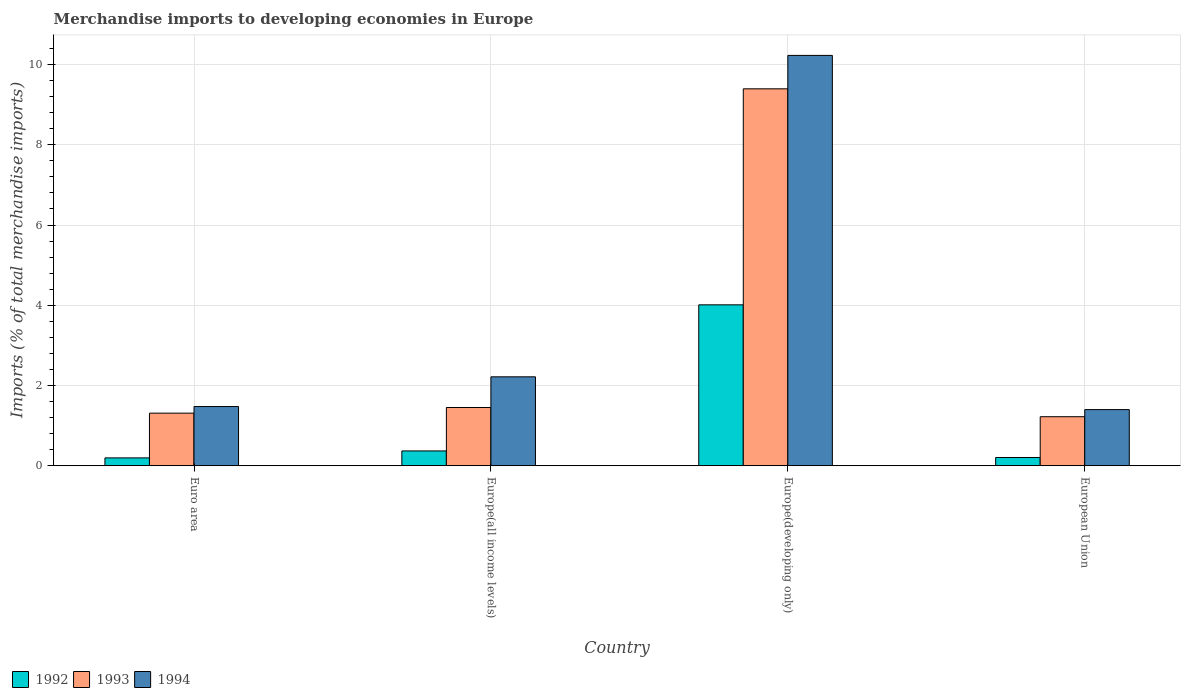How many different coloured bars are there?
Offer a very short reply. 3. Are the number of bars per tick equal to the number of legend labels?
Give a very brief answer. Yes. Are the number of bars on each tick of the X-axis equal?
Provide a short and direct response. Yes. How many bars are there on the 1st tick from the right?
Provide a short and direct response. 3. What is the label of the 2nd group of bars from the left?
Provide a succinct answer. Europe(all income levels). In how many cases, is the number of bars for a given country not equal to the number of legend labels?
Make the answer very short. 0. What is the percentage total merchandise imports in 1992 in Europe(developing only)?
Give a very brief answer. 4.01. Across all countries, what is the maximum percentage total merchandise imports in 1992?
Your answer should be compact. 4.01. Across all countries, what is the minimum percentage total merchandise imports in 1994?
Ensure brevity in your answer.  1.4. In which country was the percentage total merchandise imports in 1994 maximum?
Your answer should be compact. Europe(developing only). In which country was the percentage total merchandise imports in 1992 minimum?
Ensure brevity in your answer.  Euro area. What is the total percentage total merchandise imports in 1993 in the graph?
Make the answer very short. 13.38. What is the difference between the percentage total merchandise imports in 1992 in Euro area and that in Europe(developing only)?
Give a very brief answer. -3.82. What is the difference between the percentage total merchandise imports in 1993 in Europe(developing only) and the percentage total merchandise imports in 1994 in Europe(all income levels)?
Your answer should be very brief. 7.18. What is the average percentage total merchandise imports in 1993 per country?
Your answer should be very brief. 3.34. What is the difference between the percentage total merchandise imports of/in 1994 and percentage total merchandise imports of/in 1992 in Europe(all income levels)?
Offer a very short reply. 1.85. In how many countries, is the percentage total merchandise imports in 1993 greater than 0.8 %?
Your answer should be very brief. 4. What is the ratio of the percentage total merchandise imports in 1992 in Euro area to that in Europe(all income levels)?
Provide a short and direct response. 0.53. Is the difference between the percentage total merchandise imports in 1994 in Europe(all income levels) and European Union greater than the difference between the percentage total merchandise imports in 1992 in Europe(all income levels) and European Union?
Keep it short and to the point. Yes. What is the difference between the highest and the second highest percentage total merchandise imports in 1993?
Make the answer very short. 8.08. What is the difference between the highest and the lowest percentage total merchandise imports in 1993?
Your answer should be compact. 8.17. In how many countries, is the percentage total merchandise imports in 1994 greater than the average percentage total merchandise imports in 1994 taken over all countries?
Provide a short and direct response. 1. Is the sum of the percentage total merchandise imports in 1993 in Europe(all income levels) and European Union greater than the maximum percentage total merchandise imports in 1994 across all countries?
Your response must be concise. No. What does the 1st bar from the right in Europe(developing only) represents?
Make the answer very short. 1994. How many bars are there?
Your answer should be very brief. 12. Are all the bars in the graph horizontal?
Offer a very short reply. No. How many countries are there in the graph?
Provide a short and direct response. 4. What is the difference between two consecutive major ticks on the Y-axis?
Your answer should be very brief. 2. Are the values on the major ticks of Y-axis written in scientific E-notation?
Keep it short and to the point. No. Does the graph contain any zero values?
Give a very brief answer. No. Where does the legend appear in the graph?
Your response must be concise. Bottom left. What is the title of the graph?
Ensure brevity in your answer.  Merchandise imports to developing economies in Europe. Does "2009" appear as one of the legend labels in the graph?
Provide a succinct answer. No. What is the label or title of the Y-axis?
Offer a terse response. Imports (% of total merchandise imports). What is the Imports (% of total merchandise imports) of 1992 in Euro area?
Your answer should be very brief. 0.2. What is the Imports (% of total merchandise imports) of 1993 in Euro area?
Keep it short and to the point. 1.31. What is the Imports (% of total merchandise imports) in 1994 in Euro area?
Offer a terse response. 1.48. What is the Imports (% of total merchandise imports) in 1992 in Europe(all income levels)?
Your answer should be very brief. 0.37. What is the Imports (% of total merchandise imports) in 1993 in Europe(all income levels)?
Provide a short and direct response. 1.45. What is the Imports (% of total merchandise imports) of 1994 in Europe(all income levels)?
Give a very brief answer. 2.22. What is the Imports (% of total merchandise imports) in 1992 in Europe(developing only)?
Make the answer very short. 4.01. What is the Imports (% of total merchandise imports) in 1993 in Europe(developing only)?
Ensure brevity in your answer.  9.39. What is the Imports (% of total merchandise imports) of 1994 in Europe(developing only)?
Keep it short and to the point. 10.23. What is the Imports (% of total merchandise imports) of 1992 in European Union?
Your answer should be very brief. 0.21. What is the Imports (% of total merchandise imports) of 1993 in European Union?
Make the answer very short. 1.22. What is the Imports (% of total merchandise imports) of 1994 in European Union?
Ensure brevity in your answer.  1.4. Across all countries, what is the maximum Imports (% of total merchandise imports) in 1992?
Your response must be concise. 4.01. Across all countries, what is the maximum Imports (% of total merchandise imports) in 1993?
Provide a short and direct response. 9.39. Across all countries, what is the maximum Imports (% of total merchandise imports) in 1994?
Offer a terse response. 10.23. Across all countries, what is the minimum Imports (% of total merchandise imports) in 1992?
Offer a very short reply. 0.2. Across all countries, what is the minimum Imports (% of total merchandise imports) of 1993?
Provide a short and direct response. 1.22. Across all countries, what is the minimum Imports (% of total merchandise imports) of 1994?
Your answer should be compact. 1.4. What is the total Imports (% of total merchandise imports) in 1992 in the graph?
Your response must be concise. 4.78. What is the total Imports (% of total merchandise imports) of 1993 in the graph?
Your answer should be compact. 13.38. What is the total Imports (% of total merchandise imports) of 1994 in the graph?
Your response must be concise. 15.32. What is the difference between the Imports (% of total merchandise imports) in 1992 in Euro area and that in Europe(all income levels)?
Give a very brief answer. -0.17. What is the difference between the Imports (% of total merchandise imports) in 1993 in Euro area and that in Europe(all income levels)?
Offer a terse response. -0.14. What is the difference between the Imports (% of total merchandise imports) in 1994 in Euro area and that in Europe(all income levels)?
Your answer should be compact. -0.74. What is the difference between the Imports (% of total merchandise imports) of 1992 in Euro area and that in Europe(developing only)?
Ensure brevity in your answer.  -3.82. What is the difference between the Imports (% of total merchandise imports) in 1993 in Euro area and that in Europe(developing only)?
Keep it short and to the point. -8.08. What is the difference between the Imports (% of total merchandise imports) in 1994 in Euro area and that in Europe(developing only)?
Ensure brevity in your answer.  -8.75. What is the difference between the Imports (% of total merchandise imports) in 1992 in Euro area and that in European Union?
Provide a short and direct response. -0.01. What is the difference between the Imports (% of total merchandise imports) in 1993 in Euro area and that in European Union?
Ensure brevity in your answer.  0.09. What is the difference between the Imports (% of total merchandise imports) in 1994 in Euro area and that in European Union?
Provide a short and direct response. 0.08. What is the difference between the Imports (% of total merchandise imports) in 1992 in Europe(all income levels) and that in Europe(developing only)?
Your answer should be very brief. -3.64. What is the difference between the Imports (% of total merchandise imports) of 1993 in Europe(all income levels) and that in Europe(developing only)?
Give a very brief answer. -7.94. What is the difference between the Imports (% of total merchandise imports) in 1994 in Europe(all income levels) and that in Europe(developing only)?
Offer a terse response. -8.01. What is the difference between the Imports (% of total merchandise imports) of 1992 in Europe(all income levels) and that in European Union?
Offer a very short reply. 0.16. What is the difference between the Imports (% of total merchandise imports) in 1993 in Europe(all income levels) and that in European Union?
Provide a short and direct response. 0.23. What is the difference between the Imports (% of total merchandise imports) of 1994 in Europe(all income levels) and that in European Union?
Offer a terse response. 0.82. What is the difference between the Imports (% of total merchandise imports) of 1992 in Europe(developing only) and that in European Union?
Keep it short and to the point. 3.8. What is the difference between the Imports (% of total merchandise imports) in 1993 in Europe(developing only) and that in European Union?
Ensure brevity in your answer.  8.17. What is the difference between the Imports (% of total merchandise imports) of 1994 in Europe(developing only) and that in European Union?
Your answer should be compact. 8.83. What is the difference between the Imports (% of total merchandise imports) in 1992 in Euro area and the Imports (% of total merchandise imports) in 1993 in Europe(all income levels)?
Ensure brevity in your answer.  -1.26. What is the difference between the Imports (% of total merchandise imports) of 1992 in Euro area and the Imports (% of total merchandise imports) of 1994 in Europe(all income levels)?
Give a very brief answer. -2.02. What is the difference between the Imports (% of total merchandise imports) in 1993 in Euro area and the Imports (% of total merchandise imports) in 1994 in Europe(all income levels)?
Give a very brief answer. -0.91. What is the difference between the Imports (% of total merchandise imports) in 1992 in Euro area and the Imports (% of total merchandise imports) in 1993 in Europe(developing only)?
Provide a short and direct response. -9.2. What is the difference between the Imports (% of total merchandise imports) of 1992 in Euro area and the Imports (% of total merchandise imports) of 1994 in Europe(developing only)?
Provide a short and direct response. -10.03. What is the difference between the Imports (% of total merchandise imports) of 1993 in Euro area and the Imports (% of total merchandise imports) of 1994 in Europe(developing only)?
Keep it short and to the point. -8.92. What is the difference between the Imports (% of total merchandise imports) of 1992 in Euro area and the Imports (% of total merchandise imports) of 1993 in European Union?
Your answer should be very brief. -1.03. What is the difference between the Imports (% of total merchandise imports) of 1992 in Euro area and the Imports (% of total merchandise imports) of 1994 in European Union?
Give a very brief answer. -1.2. What is the difference between the Imports (% of total merchandise imports) of 1993 in Euro area and the Imports (% of total merchandise imports) of 1994 in European Union?
Your response must be concise. -0.09. What is the difference between the Imports (% of total merchandise imports) of 1992 in Europe(all income levels) and the Imports (% of total merchandise imports) of 1993 in Europe(developing only)?
Offer a very short reply. -9.03. What is the difference between the Imports (% of total merchandise imports) of 1992 in Europe(all income levels) and the Imports (% of total merchandise imports) of 1994 in Europe(developing only)?
Provide a succinct answer. -9.86. What is the difference between the Imports (% of total merchandise imports) in 1993 in Europe(all income levels) and the Imports (% of total merchandise imports) in 1994 in Europe(developing only)?
Provide a short and direct response. -8.78. What is the difference between the Imports (% of total merchandise imports) in 1992 in Europe(all income levels) and the Imports (% of total merchandise imports) in 1993 in European Union?
Offer a very short reply. -0.85. What is the difference between the Imports (% of total merchandise imports) of 1992 in Europe(all income levels) and the Imports (% of total merchandise imports) of 1994 in European Union?
Offer a terse response. -1.03. What is the difference between the Imports (% of total merchandise imports) in 1993 in Europe(all income levels) and the Imports (% of total merchandise imports) in 1994 in European Union?
Provide a succinct answer. 0.05. What is the difference between the Imports (% of total merchandise imports) in 1992 in Europe(developing only) and the Imports (% of total merchandise imports) in 1993 in European Union?
Your answer should be compact. 2.79. What is the difference between the Imports (% of total merchandise imports) of 1992 in Europe(developing only) and the Imports (% of total merchandise imports) of 1994 in European Union?
Give a very brief answer. 2.61. What is the difference between the Imports (% of total merchandise imports) in 1993 in Europe(developing only) and the Imports (% of total merchandise imports) in 1994 in European Union?
Keep it short and to the point. 8. What is the average Imports (% of total merchandise imports) in 1992 per country?
Provide a short and direct response. 1.2. What is the average Imports (% of total merchandise imports) in 1993 per country?
Give a very brief answer. 3.34. What is the average Imports (% of total merchandise imports) of 1994 per country?
Offer a very short reply. 3.83. What is the difference between the Imports (% of total merchandise imports) in 1992 and Imports (% of total merchandise imports) in 1993 in Euro area?
Ensure brevity in your answer.  -1.12. What is the difference between the Imports (% of total merchandise imports) in 1992 and Imports (% of total merchandise imports) in 1994 in Euro area?
Your answer should be very brief. -1.28. What is the difference between the Imports (% of total merchandise imports) of 1993 and Imports (% of total merchandise imports) of 1994 in Euro area?
Your answer should be very brief. -0.16. What is the difference between the Imports (% of total merchandise imports) of 1992 and Imports (% of total merchandise imports) of 1993 in Europe(all income levels)?
Give a very brief answer. -1.08. What is the difference between the Imports (% of total merchandise imports) of 1992 and Imports (% of total merchandise imports) of 1994 in Europe(all income levels)?
Give a very brief answer. -1.85. What is the difference between the Imports (% of total merchandise imports) of 1993 and Imports (% of total merchandise imports) of 1994 in Europe(all income levels)?
Give a very brief answer. -0.76. What is the difference between the Imports (% of total merchandise imports) of 1992 and Imports (% of total merchandise imports) of 1993 in Europe(developing only)?
Offer a very short reply. -5.38. What is the difference between the Imports (% of total merchandise imports) in 1992 and Imports (% of total merchandise imports) in 1994 in Europe(developing only)?
Offer a very short reply. -6.22. What is the difference between the Imports (% of total merchandise imports) in 1993 and Imports (% of total merchandise imports) in 1994 in Europe(developing only)?
Your answer should be very brief. -0.83. What is the difference between the Imports (% of total merchandise imports) in 1992 and Imports (% of total merchandise imports) in 1993 in European Union?
Provide a succinct answer. -1.02. What is the difference between the Imports (% of total merchandise imports) in 1992 and Imports (% of total merchandise imports) in 1994 in European Union?
Give a very brief answer. -1.19. What is the difference between the Imports (% of total merchandise imports) in 1993 and Imports (% of total merchandise imports) in 1994 in European Union?
Keep it short and to the point. -0.18. What is the ratio of the Imports (% of total merchandise imports) of 1992 in Euro area to that in Europe(all income levels)?
Ensure brevity in your answer.  0.53. What is the ratio of the Imports (% of total merchandise imports) in 1993 in Euro area to that in Europe(all income levels)?
Make the answer very short. 0.9. What is the ratio of the Imports (% of total merchandise imports) of 1994 in Euro area to that in Europe(all income levels)?
Offer a very short reply. 0.67. What is the ratio of the Imports (% of total merchandise imports) of 1992 in Euro area to that in Europe(developing only)?
Provide a short and direct response. 0.05. What is the ratio of the Imports (% of total merchandise imports) in 1993 in Euro area to that in Europe(developing only)?
Provide a short and direct response. 0.14. What is the ratio of the Imports (% of total merchandise imports) of 1994 in Euro area to that in Europe(developing only)?
Your answer should be very brief. 0.14. What is the ratio of the Imports (% of total merchandise imports) of 1992 in Euro area to that in European Union?
Offer a very short reply. 0.95. What is the ratio of the Imports (% of total merchandise imports) of 1993 in Euro area to that in European Union?
Your answer should be compact. 1.07. What is the ratio of the Imports (% of total merchandise imports) in 1994 in Euro area to that in European Union?
Ensure brevity in your answer.  1.05. What is the ratio of the Imports (% of total merchandise imports) in 1992 in Europe(all income levels) to that in Europe(developing only)?
Make the answer very short. 0.09. What is the ratio of the Imports (% of total merchandise imports) in 1993 in Europe(all income levels) to that in Europe(developing only)?
Provide a short and direct response. 0.15. What is the ratio of the Imports (% of total merchandise imports) in 1994 in Europe(all income levels) to that in Europe(developing only)?
Keep it short and to the point. 0.22. What is the ratio of the Imports (% of total merchandise imports) of 1992 in Europe(all income levels) to that in European Union?
Your answer should be very brief. 1.8. What is the ratio of the Imports (% of total merchandise imports) of 1993 in Europe(all income levels) to that in European Union?
Your answer should be compact. 1.19. What is the ratio of the Imports (% of total merchandise imports) in 1994 in Europe(all income levels) to that in European Union?
Offer a very short reply. 1.58. What is the ratio of the Imports (% of total merchandise imports) in 1992 in Europe(developing only) to that in European Union?
Your answer should be compact. 19.52. What is the ratio of the Imports (% of total merchandise imports) in 1993 in Europe(developing only) to that in European Union?
Offer a very short reply. 7.69. What is the ratio of the Imports (% of total merchandise imports) in 1994 in Europe(developing only) to that in European Union?
Make the answer very short. 7.31. What is the difference between the highest and the second highest Imports (% of total merchandise imports) of 1992?
Provide a succinct answer. 3.64. What is the difference between the highest and the second highest Imports (% of total merchandise imports) in 1993?
Offer a very short reply. 7.94. What is the difference between the highest and the second highest Imports (% of total merchandise imports) of 1994?
Your answer should be very brief. 8.01. What is the difference between the highest and the lowest Imports (% of total merchandise imports) of 1992?
Your answer should be compact. 3.82. What is the difference between the highest and the lowest Imports (% of total merchandise imports) of 1993?
Provide a short and direct response. 8.17. What is the difference between the highest and the lowest Imports (% of total merchandise imports) in 1994?
Make the answer very short. 8.83. 